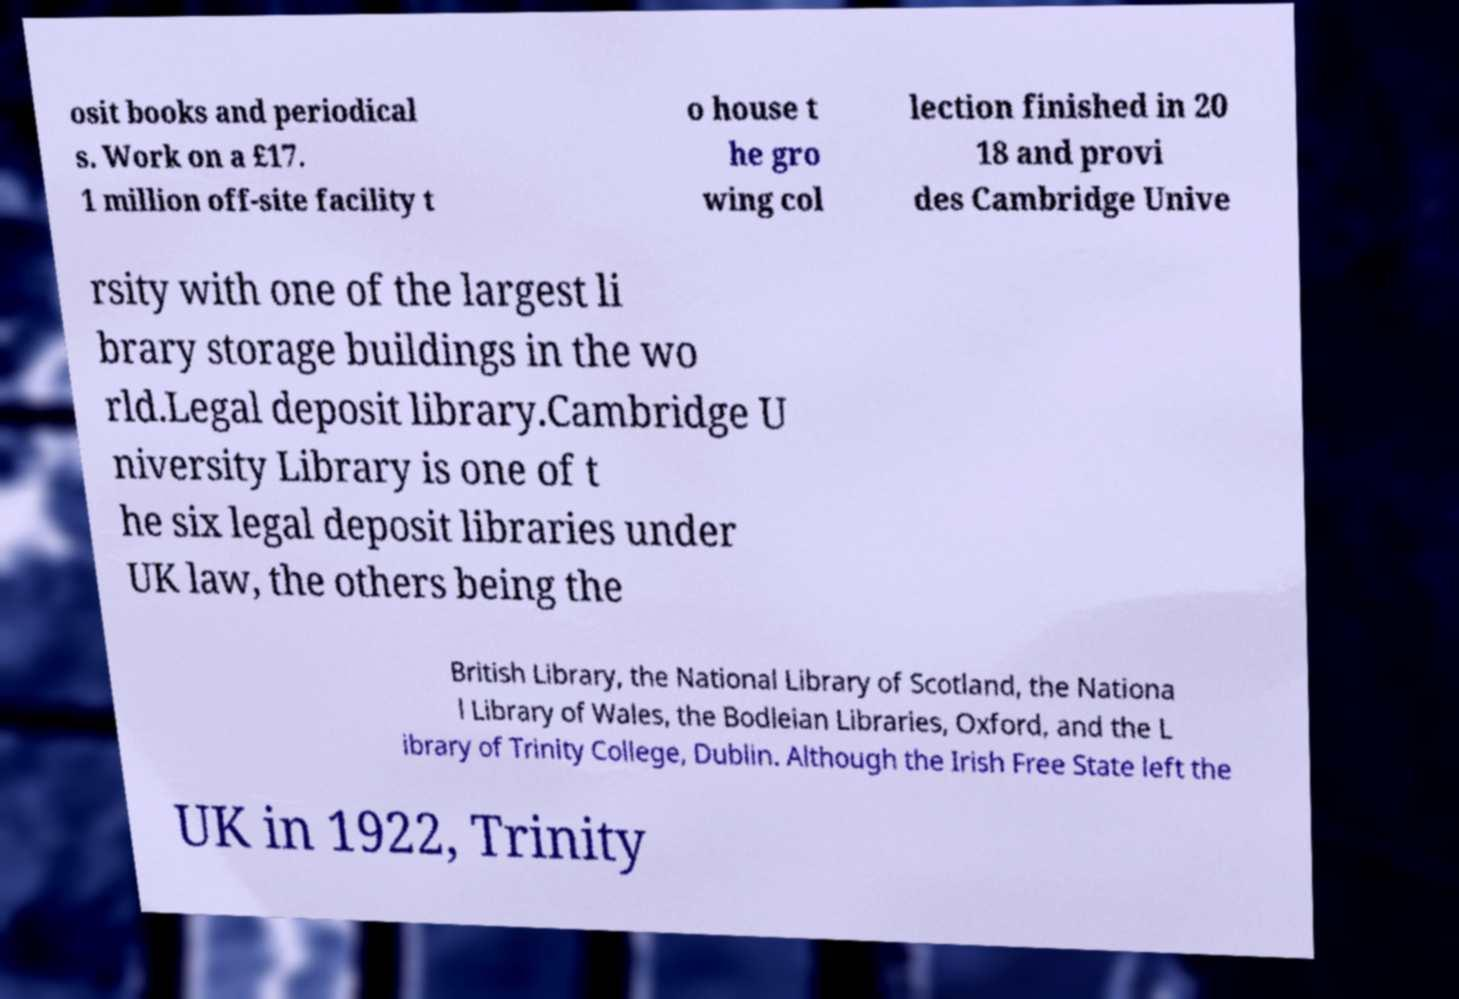Can you read and provide the text displayed in the image?This photo seems to have some interesting text. Can you extract and type it out for me? osit books and periodical s. Work on a £17. 1 million off-site facility t o house t he gro wing col lection finished in 20 18 and provi des Cambridge Unive rsity with one of the largest li brary storage buildings in the wo rld.Legal deposit library.Cambridge U niversity Library is one of t he six legal deposit libraries under UK law, the others being the British Library, the National Library of Scotland, the Nationa l Library of Wales, the Bodleian Libraries, Oxford, and the L ibrary of Trinity College, Dublin. Although the Irish Free State left the UK in 1922, Trinity 